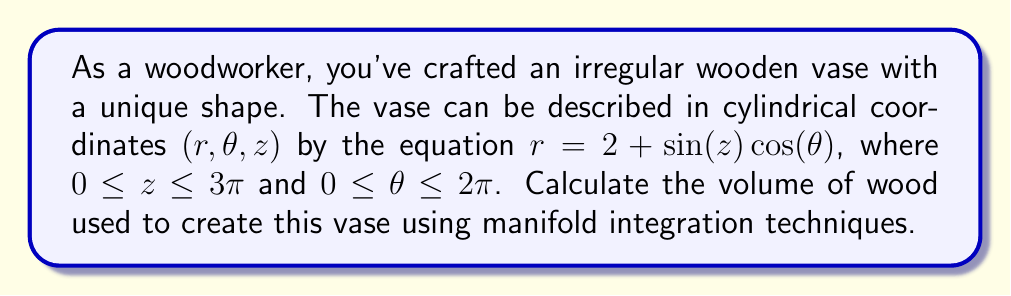Can you answer this question? To solve this problem, we'll use the volume formula for a solid in cylindrical coordinates:

$$V = \int_0^{2\pi} \int_0^{3\pi} \int_0^{2 + \sin(z) \cos(\theta)} r \, dr \, dz \, d\theta$$

Let's break this down step-by-step:

1) First, we integrate with respect to $r$:

   $$V = \int_0^{2\pi} \int_0^{3\pi} \left[\frac{r^2}{2}\right]_0^{2 + \sin(z) \cos(\theta)} \, dz \, d\theta$$

   $$V = \int_0^{2\pi} \int_0^{3\pi} \frac{1}{2}(2 + \sin(z) \cos(\theta))^2 \, dz \, d\theta$$

2) Expand the squared term:

   $$V = \int_0^{2\pi} \int_0^{3\pi} \frac{1}{2}(4 + 4\sin(z) \cos(\theta) + \sin^2(z) \cos^2(\theta)) \, dz \, d\theta$$

3) Now integrate with respect to $z$:

   $$V = \int_0^{2\pi} \left[2z + 4\cos(z) \cos(\theta) + \frac{z}{2} - \frac{\sin(2z)}{4}\cos^2(\theta)\right]_0^{3\pi} \, d\theta$$

4) Evaluate the bounds for $z$:

   $$V = \int_0^{2\pi} \left(6\pi + \frac{3\pi}{2}\right) \, d\theta$$

   Note that the terms with $\cos(z)$ and $\sin(2z)$ vanish when evaluated at $0$ and $3\pi$.

5) Finally, integrate with respect to $\theta$:

   $$V = \left(6\pi + \frac{3\pi}{2}\right) \cdot 2\pi$$

6) Simplify:

   $$V = 12\pi^2 + 3\pi^2 = 15\pi^2$$

Therefore, the volume of the wooden vase is $15\pi^2$ cubic units.
Answer: $15\pi^2$ cubic units 